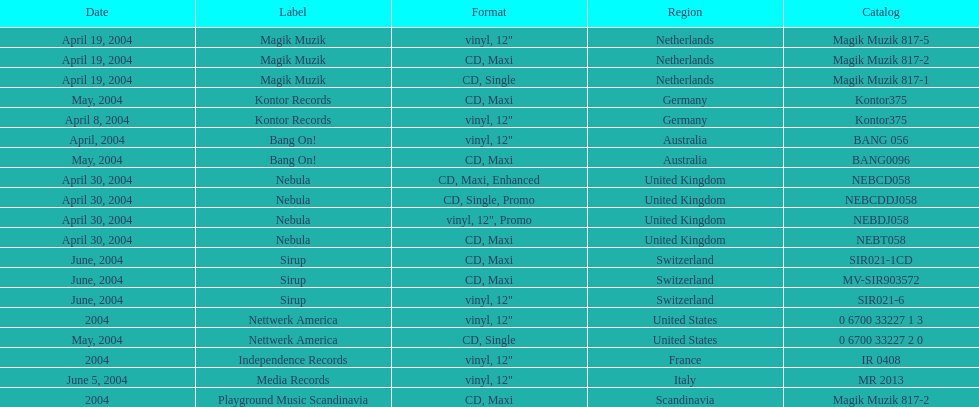What label was italy on? Media Records. 